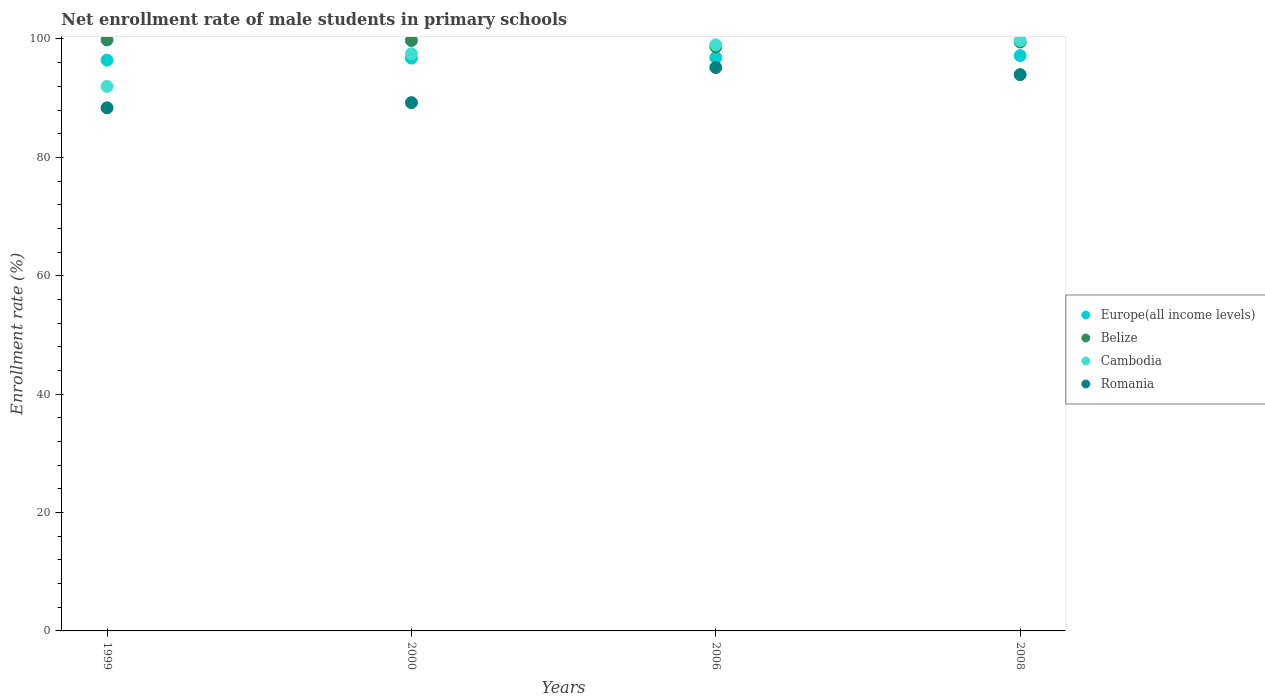How many different coloured dotlines are there?
Your response must be concise. 4. What is the net enrollment rate of male students in primary schools in Cambodia in 2008?
Ensure brevity in your answer.  99.75. Across all years, what is the maximum net enrollment rate of male students in primary schools in Europe(all income levels)?
Provide a succinct answer. 97.19. Across all years, what is the minimum net enrollment rate of male students in primary schools in Romania?
Make the answer very short. 88.37. In which year was the net enrollment rate of male students in primary schools in Belize minimum?
Make the answer very short. 2006. What is the total net enrollment rate of male students in primary schools in Cambodia in the graph?
Offer a very short reply. 388.26. What is the difference between the net enrollment rate of male students in primary schools in Europe(all income levels) in 2006 and that in 2008?
Your answer should be compact. -0.34. What is the difference between the net enrollment rate of male students in primary schools in Cambodia in 2006 and the net enrollment rate of male students in primary schools in Europe(all income levels) in 2008?
Offer a terse response. 1.83. What is the average net enrollment rate of male students in primary schools in Europe(all income levels) per year?
Offer a very short reply. 96.81. In the year 2000, what is the difference between the net enrollment rate of male students in primary schools in Belize and net enrollment rate of male students in primary schools in Romania?
Ensure brevity in your answer.  10.5. What is the ratio of the net enrollment rate of male students in primary schools in Europe(all income levels) in 2006 to that in 2008?
Your response must be concise. 1. Is the difference between the net enrollment rate of male students in primary schools in Belize in 2000 and 2008 greater than the difference between the net enrollment rate of male students in primary schools in Romania in 2000 and 2008?
Provide a succinct answer. Yes. What is the difference between the highest and the second highest net enrollment rate of male students in primary schools in Romania?
Provide a succinct answer. 1.2. What is the difference between the highest and the lowest net enrollment rate of male students in primary schools in Romania?
Your answer should be compact. 6.81. In how many years, is the net enrollment rate of male students in primary schools in Europe(all income levels) greater than the average net enrollment rate of male students in primary schools in Europe(all income levels) taken over all years?
Your answer should be very brief. 2. Is the sum of the net enrollment rate of male students in primary schools in Romania in 2006 and 2008 greater than the maximum net enrollment rate of male students in primary schools in Cambodia across all years?
Make the answer very short. Yes. Is it the case that in every year, the sum of the net enrollment rate of male students in primary schools in Belize and net enrollment rate of male students in primary schools in Cambodia  is greater than the net enrollment rate of male students in primary schools in Romania?
Your answer should be compact. Yes. Is the net enrollment rate of male students in primary schools in Romania strictly greater than the net enrollment rate of male students in primary schools in Europe(all income levels) over the years?
Your answer should be very brief. No. How many dotlines are there?
Your answer should be very brief. 4. How many years are there in the graph?
Provide a short and direct response. 4. Are the values on the major ticks of Y-axis written in scientific E-notation?
Offer a terse response. No. Does the graph contain grids?
Your answer should be very brief. No. Where does the legend appear in the graph?
Your answer should be very brief. Center right. How many legend labels are there?
Provide a short and direct response. 4. What is the title of the graph?
Your response must be concise. Net enrollment rate of male students in primary schools. What is the label or title of the Y-axis?
Your response must be concise. Enrollment rate (%). What is the Enrollment rate (%) in Europe(all income levels) in 1999?
Keep it short and to the point. 96.42. What is the Enrollment rate (%) in Belize in 1999?
Give a very brief answer. 99.83. What is the Enrollment rate (%) of Cambodia in 1999?
Ensure brevity in your answer.  91.98. What is the Enrollment rate (%) in Romania in 1999?
Your response must be concise. 88.37. What is the Enrollment rate (%) in Europe(all income levels) in 2000?
Ensure brevity in your answer.  96.77. What is the Enrollment rate (%) in Belize in 2000?
Your answer should be very brief. 99.75. What is the Enrollment rate (%) of Cambodia in 2000?
Keep it short and to the point. 97.51. What is the Enrollment rate (%) of Romania in 2000?
Keep it short and to the point. 89.24. What is the Enrollment rate (%) in Europe(all income levels) in 2006?
Ensure brevity in your answer.  96.86. What is the Enrollment rate (%) of Belize in 2006?
Keep it short and to the point. 98.67. What is the Enrollment rate (%) of Cambodia in 2006?
Provide a short and direct response. 99.02. What is the Enrollment rate (%) of Romania in 2006?
Offer a very short reply. 95.18. What is the Enrollment rate (%) in Europe(all income levels) in 2008?
Ensure brevity in your answer.  97.19. What is the Enrollment rate (%) of Belize in 2008?
Ensure brevity in your answer.  99.49. What is the Enrollment rate (%) of Cambodia in 2008?
Your response must be concise. 99.75. What is the Enrollment rate (%) of Romania in 2008?
Offer a terse response. 93.98. Across all years, what is the maximum Enrollment rate (%) in Europe(all income levels)?
Keep it short and to the point. 97.19. Across all years, what is the maximum Enrollment rate (%) of Belize?
Offer a very short reply. 99.83. Across all years, what is the maximum Enrollment rate (%) of Cambodia?
Ensure brevity in your answer.  99.75. Across all years, what is the maximum Enrollment rate (%) of Romania?
Give a very brief answer. 95.18. Across all years, what is the minimum Enrollment rate (%) in Europe(all income levels)?
Provide a succinct answer. 96.42. Across all years, what is the minimum Enrollment rate (%) in Belize?
Your answer should be very brief. 98.67. Across all years, what is the minimum Enrollment rate (%) of Cambodia?
Your answer should be very brief. 91.98. Across all years, what is the minimum Enrollment rate (%) of Romania?
Keep it short and to the point. 88.37. What is the total Enrollment rate (%) of Europe(all income levels) in the graph?
Your answer should be compact. 387.24. What is the total Enrollment rate (%) of Belize in the graph?
Offer a terse response. 397.74. What is the total Enrollment rate (%) of Cambodia in the graph?
Ensure brevity in your answer.  388.26. What is the total Enrollment rate (%) of Romania in the graph?
Your answer should be very brief. 366.76. What is the difference between the Enrollment rate (%) in Europe(all income levels) in 1999 and that in 2000?
Ensure brevity in your answer.  -0.35. What is the difference between the Enrollment rate (%) in Belize in 1999 and that in 2000?
Your response must be concise. 0.09. What is the difference between the Enrollment rate (%) in Cambodia in 1999 and that in 2000?
Offer a terse response. -5.53. What is the difference between the Enrollment rate (%) of Romania in 1999 and that in 2000?
Your answer should be compact. -0.88. What is the difference between the Enrollment rate (%) of Europe(all income levels) in 1999 and that in 2006?
Make the answer very short. -0.43. What is the difference between the Enrollment rate (%) of Belize in 1999 and that in 2006?
Make the answer very short. 1.17. What is the difference between the Enrollment rate (%) of Cambodia in 1999 and that in 2006?
Your answer should be compact. -7.04. What is the difference between the Enrollment rate (%) of Romania in 1999 and that in 2006?
Your response must be concise. -6.81. What is the difference between the Enrollment rate (%) in Europe(all income levels) in 1999 and that in 2008?
Ensure brevity in your answer.  -0.77. What is the difference between the Enrollment rate (%) in Belize in 1999 and that in 2008?
Offer a very short reply. 0.34. What is the difference between the Enrollment rate (%) in Cambodia in 1999 and that in 2008?
Offer a terse response. -7.77. What is the difference between the Enrollment rate (%) in Romania in 1999 and that in 2008?
Provide a short and direct response. -5.61. What is the difference between the Enrollment rate (%) of Europe(all income levels) in 2000 and that in 2006?
Ensure brevity in your answer.  -0.09. What is the difference between the Enrollment rate (%) in Belize in 2000 and that in 2006?
Make the answer very short. 1.08. What is the difference between the Enrollment rate (%) of Cambodia in 2000 and that in 2006?
Keep it short and to the point. -1.51. What is the difference between the Enrollment rate (%) of Romania in 2000 and that in 2006?
Give a very brief answer. -5.93. What is the difference between the Enrollment rate (%) in Europe(all income levels) in 2000 and that in 2008?
Offer a very short reply. -0.42. What is the difference between the Enrollment rate (%) in Belize in 2000 and that in 2008?
Provide a short and direct response. 0.25. What is the difference between the Enrollment rate (%) in Cambodia in 2000 and that in 2008?
Offer a terse response. -2.24. What is the difference between the Enrollment rate (%) in Romania in 2000 and that in 2008?
Your answer should be very brief. -4.73. What is the difference between the Enrollment rate (%) of Europe(all income levels) in 2006 and that in 2008?
Make the answer very short. -0.34. What is the difference between the Enrollment rate (%) in Belize in 2006 and that in 2008?
Offer a terse response. -0.83. What is the difference between the Enrollment rate (%) in Cambodia in 2006 and that in 2008?
Keep it short and to the point. -0.73. What is the difference between the Enrollment rate (%) of Romania in 2006 and that in 2008?
Offer a terse response. 1.2. What is the difference between the Enrollment rate (%) in Europe(all income levels) in 1999 and the Enrollment rate (%) in Belize in 2000?
Your answer should be compact. -3.33. What is the difference between the Enrollment rate (%) in Europe(all income levels) in 1999 and the Enrollment rate (%) in Cambodia in 2000?
Provide a short and direct response. -1.09. What is the difference between the Enrollment rate (%) of Europe(all income levels) in 1999 and the Enrollment rate (%) of Romania in 2000?
Offer a very short reply. 7.18. What is the difference between the Enrollment rate (%) of Belize in 1999 and the Enrollment rate (%) of Cambodia in 2000?
Your answer should be very brief. 2.33. What is the difference between the Enrollment rate (%) of Belize in 1999 and the Enrollment rate (%) of Romania in 2000?
Keep it short and to the point. 10.59. What is the difference between the Enrollment rate (%) of Cambodia in 1999 and the Enrollment rate (%) of Romania in 2000?
Ensure brevity in your answer.  2.74. What is the difference between the Enrollment rate (%) of Europe(all income levels) in 1999 and the Enrollment rate (%) of Belize in 2006?
Your answer should be very brief. -2.24. What is the difference between the Enrollment rate (%) of Europe(all income levels) in 1999 and the Enrollment rate (%) of Cambodia in 2006?
Your answer should be very brief. -2.6. What is the difference between the Enrollment rate (%) of Europe(all income levels) in 1999 and the Enrollment rate (%) of Romania in 2006?
Provide a succinct answer. 1.24. What is the difference between the Enrollment rate (%) in Belize in 1999 and the Enrollment rate (%) in Cambodia in 2006?
Offer a very short reply. 0.81. What is the difference between the Enrollment rate (%) in Belize in 1999 and the Enrollment rate (%) in Romania in 2006?
Your response must be concise. 4.66. What is the difference between the Enrollment rate (%) in Cambodia in 1999 and the Enrollment rate (%) in Romania in 2006?
Ensure brevity in your answer.  -3.2. What is the difference between the Enrollment rate (%) in Europe(all income levels) in 1999 and the Enrollment rate (%) in Belize in 2008?
Give a very brief answer. -3.07. What is the difference between the Enrollment rate (%) in Europe(all income levels) in 1999 and the Enrollment rate (%) in Cambodia in 2008?
Your answer should be compact. -3.33. What is the difference between the Enrollment rate (%) of Europe(all income levels) in 1999 and the Enrollment rate (%) of Romania in 2008?
Keep it short and to the point. 2.45. What is the difference between the Enrollment rate (%) of Belize in 1999 and the Enrollment rate (%) of Cambodia in 2008?
Your answer should be very brief. 0.08. What is the difference between the Enrollment rate (%) in Belize in 1999 and the Enrollment rate (%) in Romania in 2008?
Your answer should be very brief. 5.86. What is the difference between the Enrollment rate (%) of Cambodia in 1999 and the Enrollment rate (%) of Romania in 2008?
Ensure brevity in your answer.  -1.99. What is the difference between the Enrollment rate (%) of Europe(all income levels) in 2000 and the Enrollment rate (%) of Belize in 2006?
Your response must be concise. -1.9. What is the difference between the Enrollment rate (%) of Europe(all income levels) in 2000 and the Enrollment rate (%) of Cambodia in 2006?
Make the answer very short. -2.25. What is the difference between the Enrollment rate (%) in Europe(all income levels) in 2000 and the Enrollment rate (%) in Romania in 2006?
Give a very brief answer. 1.59. What is the difference between the Enrollment rate (%) of Belize in 2000 and the Enrollment rate (%) of Cambodia in 2006?
Provide a succinct answer. 0.72. What is the difference between the Enrollment rate (%) of Belize in 2000 and the Enrollment rate (%) of Romania in 2006?
Provide a succinct answer. 4.57. What is the difference between the Enrollment rate (%) of Cambodia in 2000 and the Enrollment rate (%) of Romania in 2006?
Provide a succinct answer. 2.33. What is the difference between the Enrollment rate (%) in Europe(all income levels) in 2000 and the Enrollment rate (%) in Belize in 2008?
Your answer should be very brief. -2.72. What is the difference between the Enrollment rate (%) in Europe(all income levels) in 2000 and the Enrollment rate (%) in Cambodia in 2008?
Your answer should be compact. -2.98. What is the difference between the Enrollment rate (%) of Europe(all income levels) in 2000 and the Enrollment rate (%) of Romania in 2008?
Your answer should be compact. 2.79. What is the difference between the Enrollment rate (%) of Belize in 2000 and the Enrollment rate (%) of Cambodia in 2008?
Ensure brevity in your answer.  -0.01. What is the difference between the Enrollment rate (%) of Belize in 2000 and the Enrollment rate (%) of Romania in 2008?
Your answer should be very brief. 5.77. What is the difference between the Enrollment rate (%) of Cambodia in 2000 and the Enrollment rate (%) of Romania in 2008?
Your response must be concise. 3.53. What is the difference between the Enrollment rate (%) in Europe(all income levels) in 2006 and the Enrollment rate (%) in Belize in 2008?
Your answer should be very brief. -2.64. What is the difference between the Enrollment rate (%) of Europe(all income levels) in 2006 and the Enrollment rate (%) of Cambodia in 2008?
Offer a terse response. -2.9. What is the difference between the Enrollment rate (%) in Europe(all income levels) in 2006 and the Enrollment rate (%) in Romania in 2008?
Offer a very short reply. 2.88. What is the difference between the Enrollment rate (%) of Belize in 2006 and the Enrollment rate (%) of Cambodia in 2008?
Give a very brief answer. -1.09. What is the difference between the Enrollment rate (%) of Belize in 2006 and the Enrollment rate (%) of Romania in 2008?
Ensure brevity in your answer.  4.69. What is the difference between the Enrollment rate (%) in Cambodia in 2006 and the Enrollment rate (%) in Romania in 2008?
Your answer should be compact. 5.05. What is the average Enrollment rate (%) of Europe(all income levels) per year?
Offer a very short reply. 96.81. What is the average Enrollment rate (%) of Belize per year?
Your answer should be very brief. 99.43. What is the average Enrollment rate (%) in Cambodia per year?
Give a very brief answer. 97.07. What is the average Enrollment rate (%) of Romania per year?
Provide a short and direct response. 91.69. In the year 1999, what is the difference between the Enrollment rate (%) of Europe(all income levels) and Enrollment rate (%) of Belize?
Make the answer very short. -3.41. In the year 1999, what is the difference between the Enrollment rate (%) in Europe(all income levels) and Enrollment rate (%) in Cambodia?
Offer a very short reply. 4.44. In the year 1999, what is the difference between the Enrollment rate (%) of Europe(all income levels) and Enrollment rate (%) of Romania?
Give a very brief answer. 8.05. In the year 1999, what is the difference between the Enrollment rate (%) in Belize and Enrollment rate (%) in Cambodia?
Your answer should be compact. 7.85. In the year 1999, what is the difference between the Enrollment rate (%) in Belize and Enrollment rate (%) in Romania?
Your answer should be compact. 11.47. In the year 1999, what is the difference between the Enrollment rate (%) in Cambodia and Enrollment rate (%) in Romania?
Make the answer very short. 3.61. In the year 2000, what is the difference between the Enrollment rate (%) of Europe(all income levels) and Enrollment rate (%) of Belize?
Your answer should be compact. -2.98. In the year 2000, what is the difference between the Enrollment rate (%) in Europe(all income levels) and Enrollment rate (%) in Cambodia?
Your answer should be compact. -0.74. In the year 2000, what is the difference between the Enrollment rate (%) in Europe(all income levels) and Enrollment rate (%) in Romania?
Offer a terse response. 7.53. In the year 2000, what is the difference between the Enrollment rate (%) of Belize and Enrollment rate (%) of Cambodia?
Keep it short and to the point. 2.24. In the year 2000, what is the difference between the Enrollment rate (%) of Belize and Enrollment rate (%) of Romania?
Keep it short and to the point. 10.5. In the year 2000, what is the difference between the Enrollment rate (%) in Cambodia and Enrollment rate (%) in Romania?
Ensure brevity in your answer.  8.27. In the year 2006, what is the difference between the Enrollment rate (%) of Europe(all income levels) and Enrollment rate (%) of Belize?
Ensure brevity in your answer.  -1.81. In the year 2006, what is the difference between the Enrollment rate (%) of Europe(all income levels) and Enrollment rate (%) of Cambodia?
Provide a succinct answer. -2.17. In the year 2006, what is the difference between the Enrollment rate (%) of Europe(all income levels) and Enrollment rate (%) of Romania?
Provide a short and direct response. 1.68. In the year 2006, what is the difference between the Enrollment rate (%) of Belize and Enrollment rate (%) of Cambodia?
Your answer should be very brief. -0.36. In the year 2006, what is the difference between the Enrollment rate (%) of Belize and Enrollment rate (%) of Romania?
Your answer should be compact. 3.49. In the year 2006, what is the difference between the Enrollment rate (%) in Cambodia and Enrollment rate (%) in Romania?
Your answer should be very brief. 3.85. In the year 2008, what is the difference between the Enrollment rate (%) of Europe(all income levels) and Enrollment rate (%) of Belize?
Provide a short and direct response. -2.3. In the year 2008, what is the difference between the Enrollment rate (%) of Europe(all income levels) and Enrollment rate (%) of Cambodia?
Your answer should be very brief. -2.56. In the year 2008, what is the difference between the Enrollment rate (%) of Europe(all income levels) and Enrollment rate (%) of Romania?
Your answer should be very brief. 3.22. In the year 2008, what is the difference between the Enrollment rate (%) of Belize and Enrollment rate (%) of Cambodia?
Your answer should be very brief. -0.26. In the year 2008, what is the difference between the Enrollment rate (%) of Belize and Enrollment rate (%) of Romania?
Provide a short and direct response. 5.52. In the year 2008, what is the difference between the Enrollment rate (%) in Cambodia and Enrollment rate (%) in Romania?
Your answer should be compact. 5.78. What is the ratio of the Enrollment rate (%) in Belize in 1999 to that in 2000?
Keep it short and to the point. 1. What is the ratio of the Enrollment rate (%) in Cambodia in 1999 to that in 2000?
Provide a short and direct response. 0.94. What is the ratio of the Enrollment rate (%) in Romania in 1999 to that in 2000?
Make the answer very short. 0.99. What is the ratio of the Enrollment rate (%) of Belize in 1999 to that in 2006?
Give a very brief answer. 1.01. What is the ratio of the Enrollment rate (%) of Cambodia in 1999 to that in 2006?
Provide a short and direct response. 0.93. What is the ratio of the Enrollment rate (%) of Romania in 1999 to that in 2006?
Offer a terse response. 0.93. What is the ratio of the Enrollment rate (%) of Europe(all income levels) in 1999 to that in 2008?
Your response must be concise. 0.99. What is the ratio of the Enrollment rate (%) in Belize in 1999 to that in 2008?
Offer a terse response. 1. What is the ratio of the Enrollment rate (%) of Cambodia in 1999 to that in 2008?
Keep it short and to the point. 0.92. What is the ratio of the Enrollment rate (%) in Romania in 1999 to that in 2008?
Ensure brevity in your answer.  0.94. What is the ratio of the Enrollment rate (%) in Europe(all income levels) in 2000 to that in 2006?
Provide a succinct answer. 1. What is the ratio of the Enrollment rate (%) of Cambodia in 2000 to that in 2006?
Give a very brief answer. 0.98. What is the ratio of the Enrollment rate (%) in Romania in 2000 to that in 2006?
Offer a very short reply. 0.94. What is the ratio of the Enrollment rate (%) of Belize in 2000 to that in 2008?
Provide a succinct answer. 1. What is the ratio of the Enrollment rate (%) of Cambodia in 2000 to that in 2008?
Give a very brief answer. 0.98. What is the ratio of the Enrollment rate (%) of Romania in 2000 to that in 2008?
Make the answer very short. 0.95. What is the ratio of the Enrollment rate (%) in Europe(all income levels) in 2006 to that in 2008?
Make the answer very short. 1. What is the ratio of the Enrollment rate (%) in Belize in 2006 to that in 2008?
Your answer should be very brief. 0.99. What is the ratio of the Enrollment rate (%) in Romania in 2006 to that in 2008?
Your response must be concise. 1.01. What is the difference between the highest and the second highest Enrollment rate (%) in Europe(all income levels)?
Provide a succinct answer. 0.34. What is the difference between the highest and the second highest Enrollment rate (%) of Belize?
Make the answer very short. 0.09. What is the difference between the highest and the second highest Enrollment rate (%) of Cambodia?
Provide a succinct answer. 0.73. What is the difference between the highest and the second highest Enrollment rate (%) in Romania?
Give a very brief answer. 1.2. What is the difference between the highest and the lowest Enrollment rate (%) in Europe(all income levels)?
Keep it short and to the point. 0.77. What is the difference between the highest and the lowest Enrollment rate (%) in Belize?
Give a very brief answer. 1.17. What is the difference between the highest and the lowest Enrollment rate (%) of Cambodia?
Keep it short and to the point. 7.77. What is the difference between the highest and the lowest Enrollment rate (%) of Romania?
Provide a short and direct response. 6.81. 